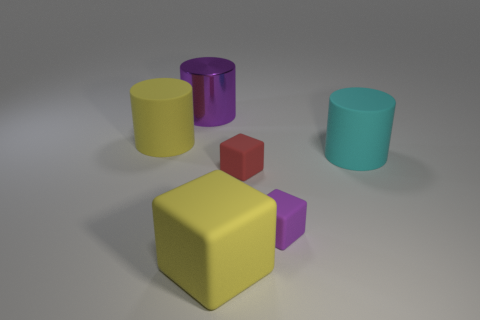What materials do these objects look like they are made from? The objects in the image appear to have a matte finish and could be made of plastic, as indicated by their uniform color and lack of texture common to other materials like metal or wood. 